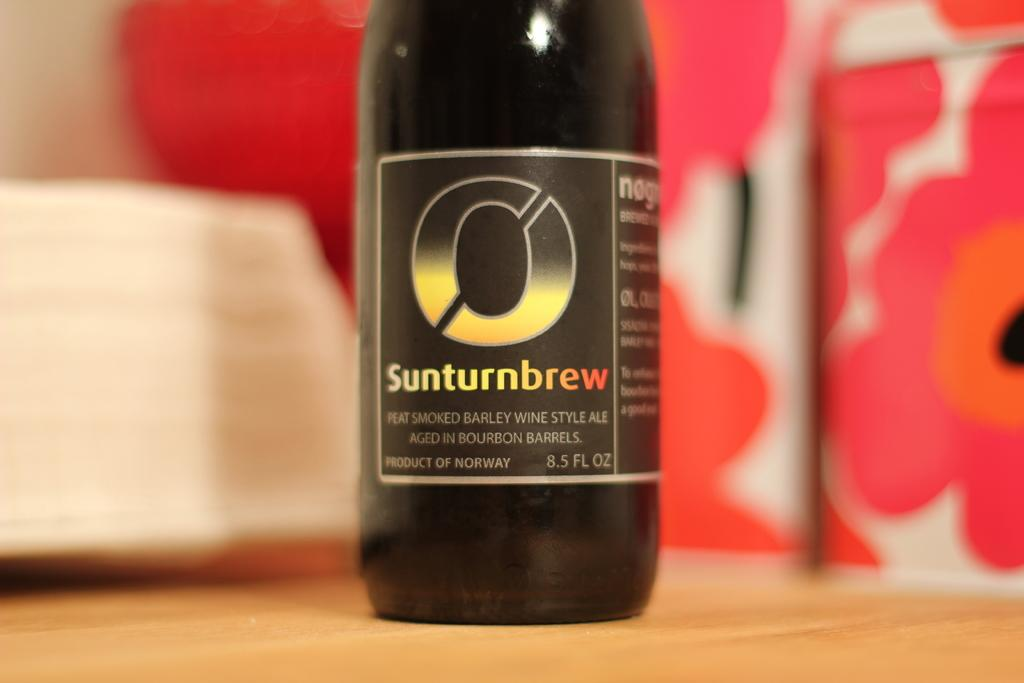<image>
Share a concise interpretation of the image provided. A bottle of Sunturnbrew wine style ale sitting on a table. 